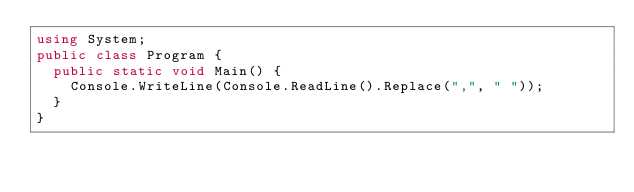<code> <loc_0><loc_0><loc_500><loc_500><_C#_>using System;
public class Program {
  public static void Main() {
    Console.WriteLine(Console.ReadLine().Replace(",", " "));
  }
}
</code> 